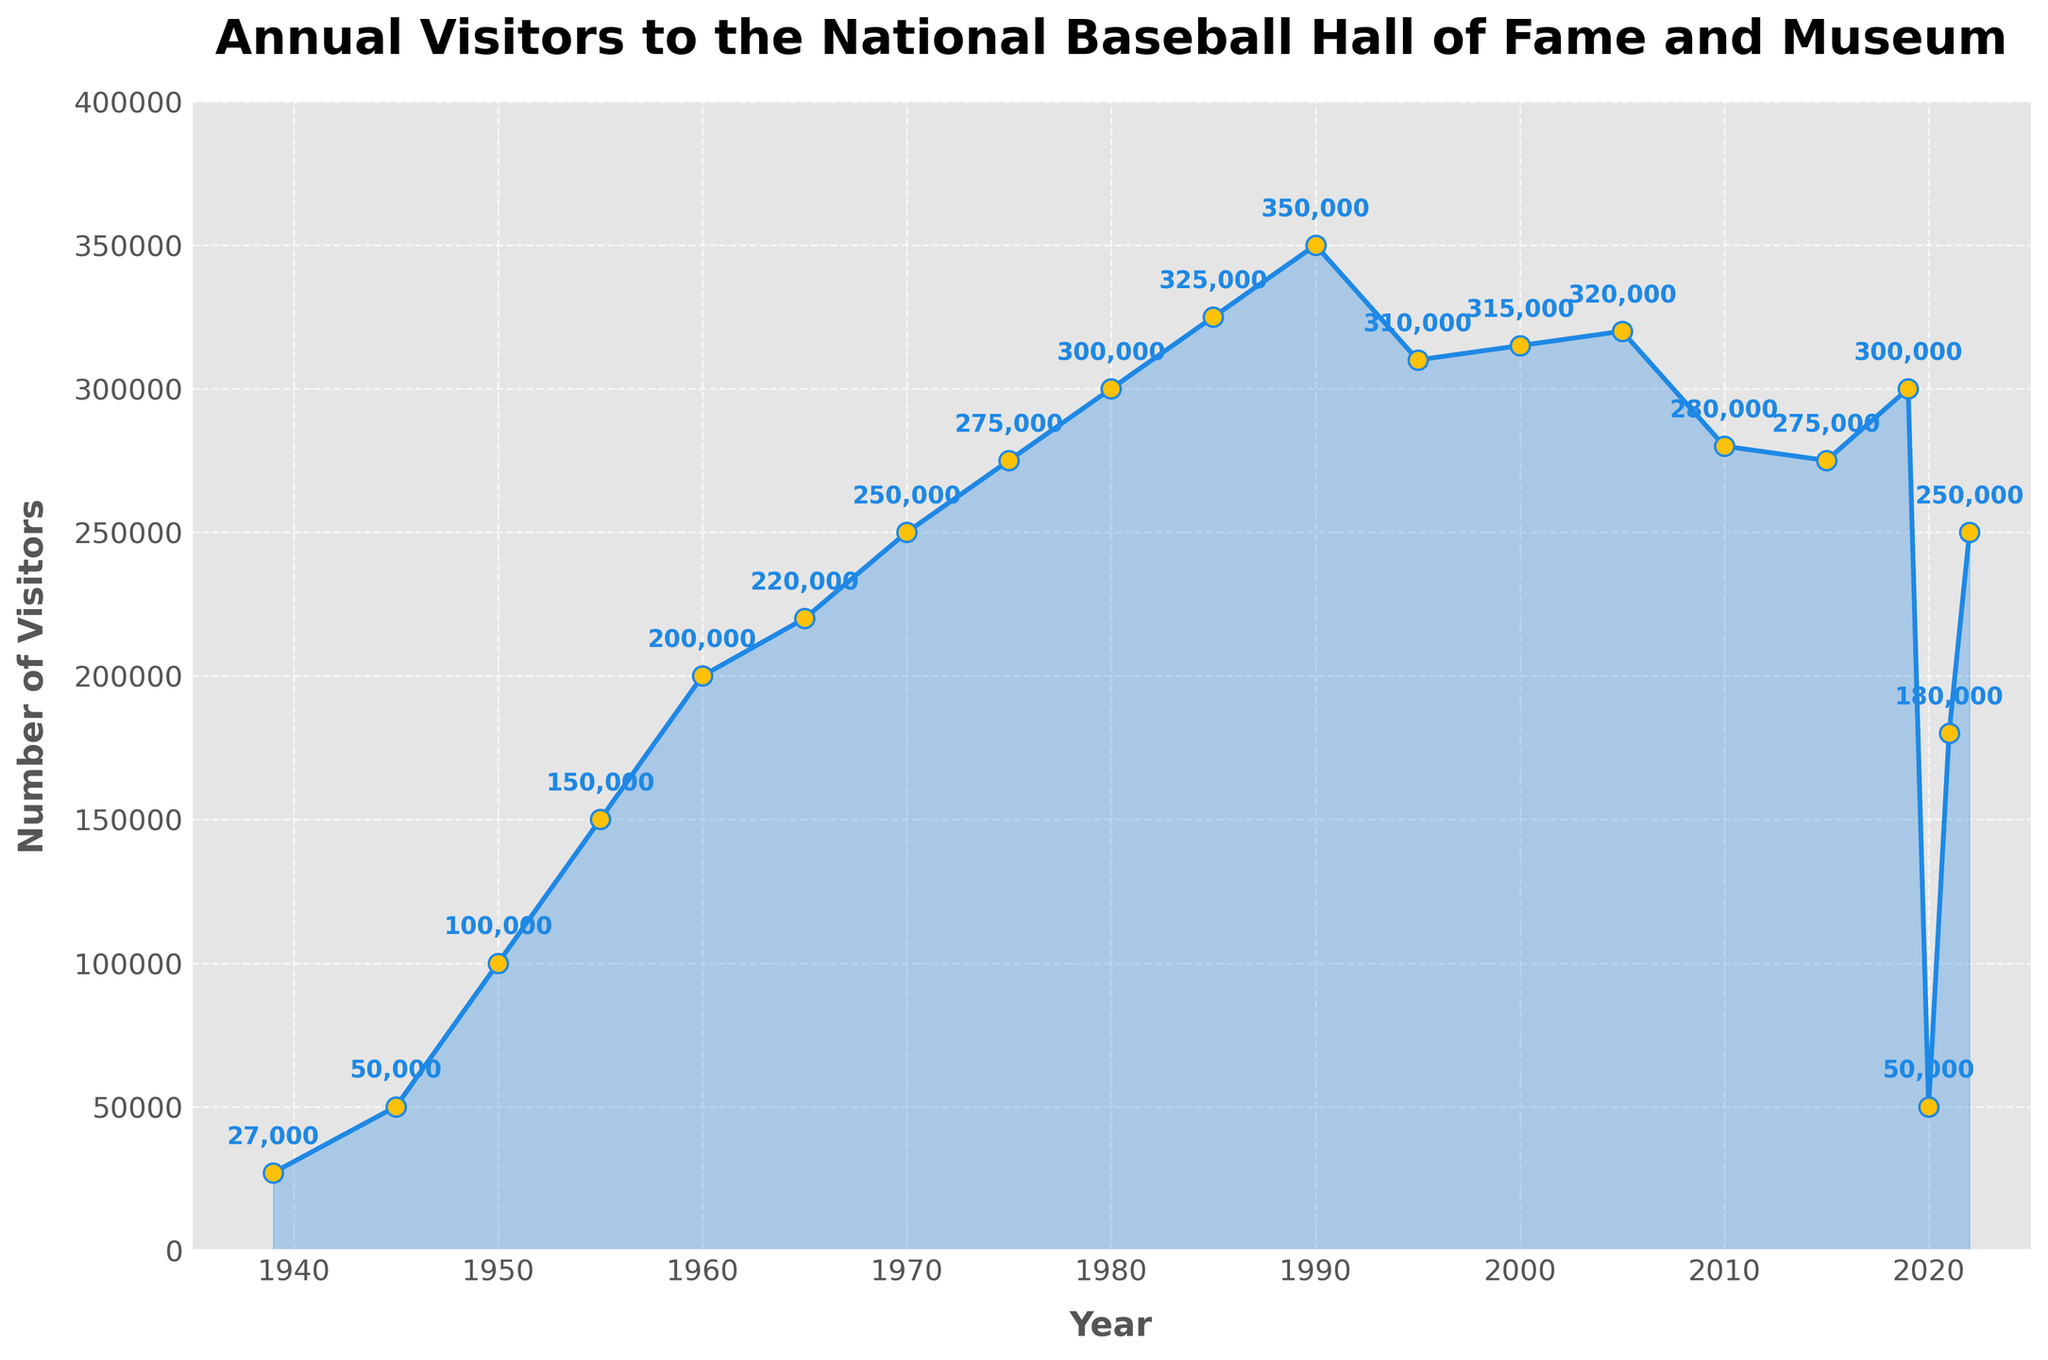What's the highest number of visitors recorded? The line chart shows the annual number of visitors, and the highest point on the line corresponds to the highest number of visitors. The highest number annotated on the plot is 350,000 in 1990.
Answer: 350,000 How many visitors did the museum have in its opening year? The line chart starts from the year 1939, and the number of visitors for that year is annotated at the beginning of the line. The value shown is 27,000.
Answer: 27,000 In which year did the number of visitors first reach 300,000? Scan the line chart for the first year when annotations indicate the visitor number reaching 300,000. This occurs between 1980 and 1985, where 1980 has 300,000 visitors.
Answer: 1980 By how much did the number of visitors change from 1985 to 1990? Locate the visitor numbers for 1985 (325,000) and for 1990 (350,000). Subtract 325,000 from 350,000. Calculation: 350,000 - 325,000 = 25,000.
Answer: 25,000 What is the average number of visitors between 2010 and 2019? Identify the visitor numbers for each year from 2010 to 2019: 280,000 (2010), 275,000 (2015), and 300,000 (2019). Sum these values and divide by the number of years. Calculation: (280,000 + 275,000 + 300,000) / 3 = 855,000 / 3 = 285,000.
Answer: 285,000 How did the number of visitors in 2020 compare to 2021? The visitor number in 2020 is 50,000 and in 2021 it is 180,000. To compare, subtract the 2020 value from the 2021 value. Calculation: 180,000 - 50,000 = 130,000.
Answer: 130,000 What was the trend in visitor numbers from 2000 to 2005? Observe the points on the line chart for 2000 (315,000) and 2005 (320,000). The visitor numbers slightly increase from 315,000 to 320,000.
Answer: Slight increase Between which two consecutive years did the largest decrease in visitors occur? Check the annotations for each pair of consecutive years and note the differences: The most significant drop is between 2019 (300,000) and 2020 (50,000). Calculation: 300,000 - 50,000 = 250,000.
Answer: 2019 and 2020 Estimate the visitor number in 1950 and compare it to that in 1960. The visitor number in 1950 is 100,000 and in 1960 it is 200,000. Compare these values to find that 1960 has approximately double the visitors of 1950.
Answer: Doubled What is the average annual growth rate in visitor numbers from 1939 to 1950? The visitor numbers grow from 27,000 in 1939 to 100,000 in 1950. Calculate the growth rate using the formula for average annual growth rate: (Ending Value / Beginning Value)^(1/Number of Years) - 1. For these years: (100,000 / 27,000)^(1/11) - 1.
Answer: 10.4% 